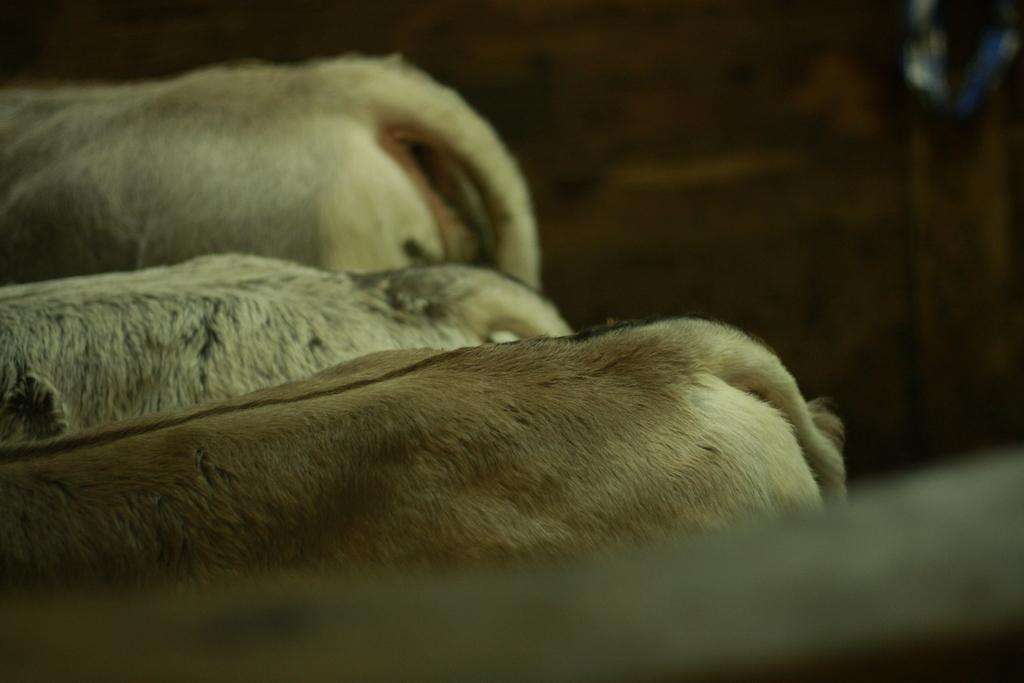How many animals are present in the image? There are three animals in the image. What part of the animals can be seen in the image? Only the tails of the animals are visible in the image. Can you describe the background of the image? The background of the image is blurry. What type of plantation can be seen in the background of the image? There is no plantation present in the image; the background is blurry. What is the wrist of the animal doing in the image? The animals in the image do not have visible wrists, as only their tails are visible. 